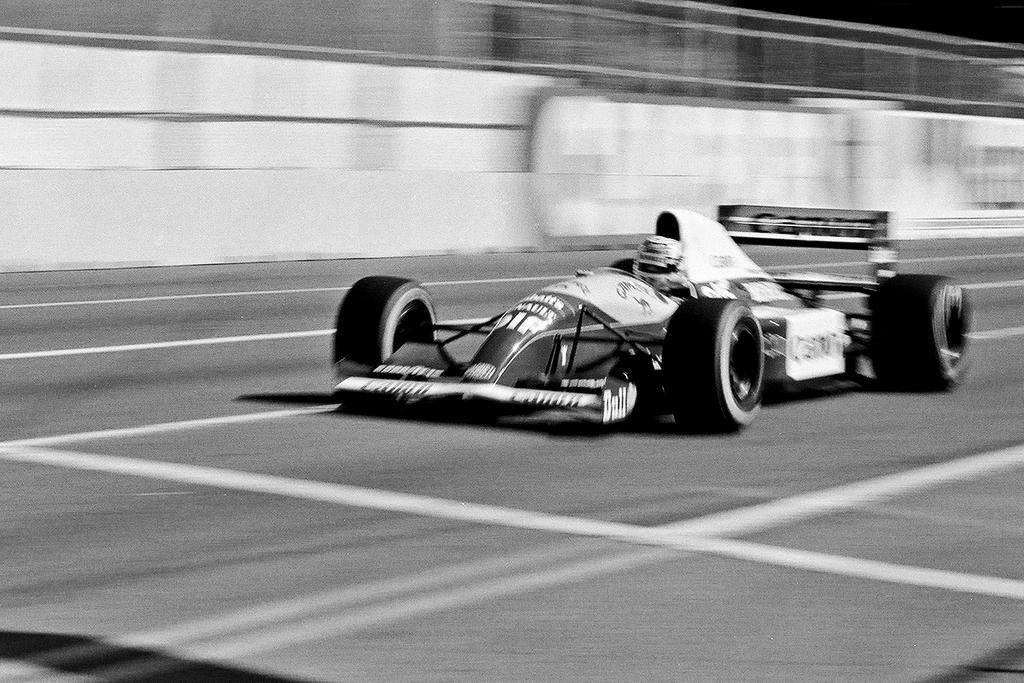How would you summarize this image in a sentence or two? Background portion of the picture is blur. In this picture we can see a vehicle on the road. This is a black and white picture. 